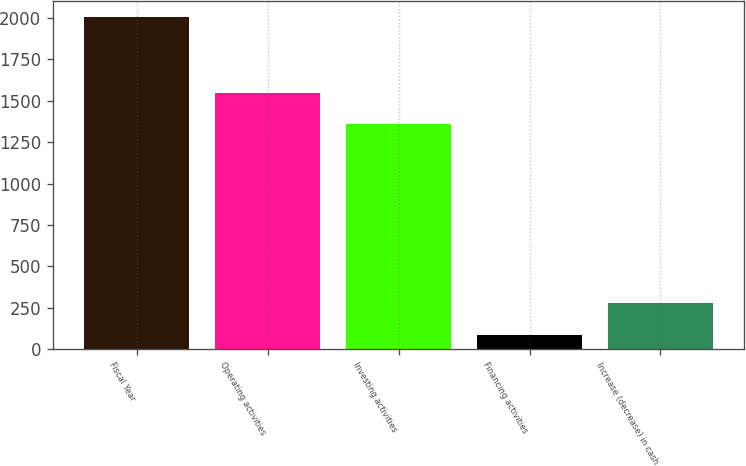<chart> <loc_0><loc_0><loc_500><loc_500><bar_chart><fcel>Fiscal Year<fcel>Operating activities<fcel>Investing activities<fcel>Financing activities<fcel>Increase (decrease) in cash<nl><fcel>2004<fcel>1549.7<fcel>1358<fcel>87<fcel>278.7<nl></chart> 